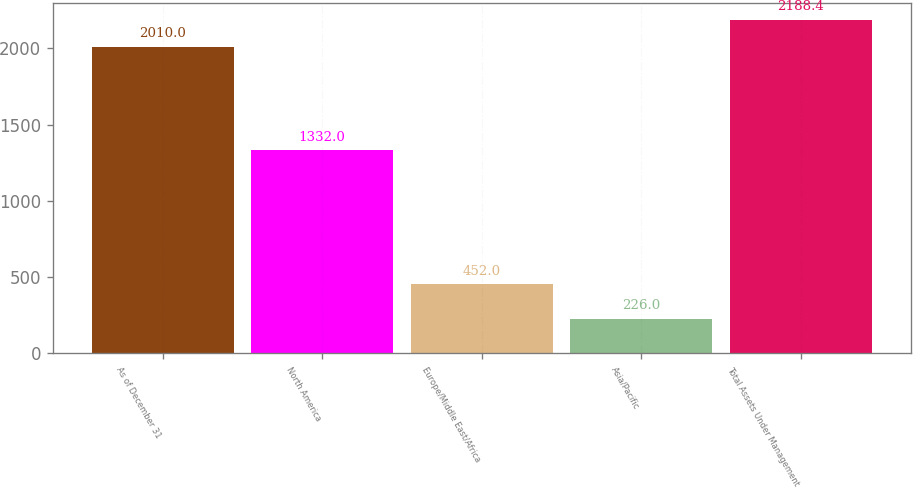Convert chart. <chart><loc_0><loc_0><loc_500><loc_500><bar_chart><fcel>As of December 31<fcel>North America<fcel>Europe/Middle East/Africa<fcel>Asia/Pacific<fcel>Total Assets Under Management<nl><fcel>2010<fcel>1332<fcel>452<fcel>226<fcel>2188.4<nl></chart> 